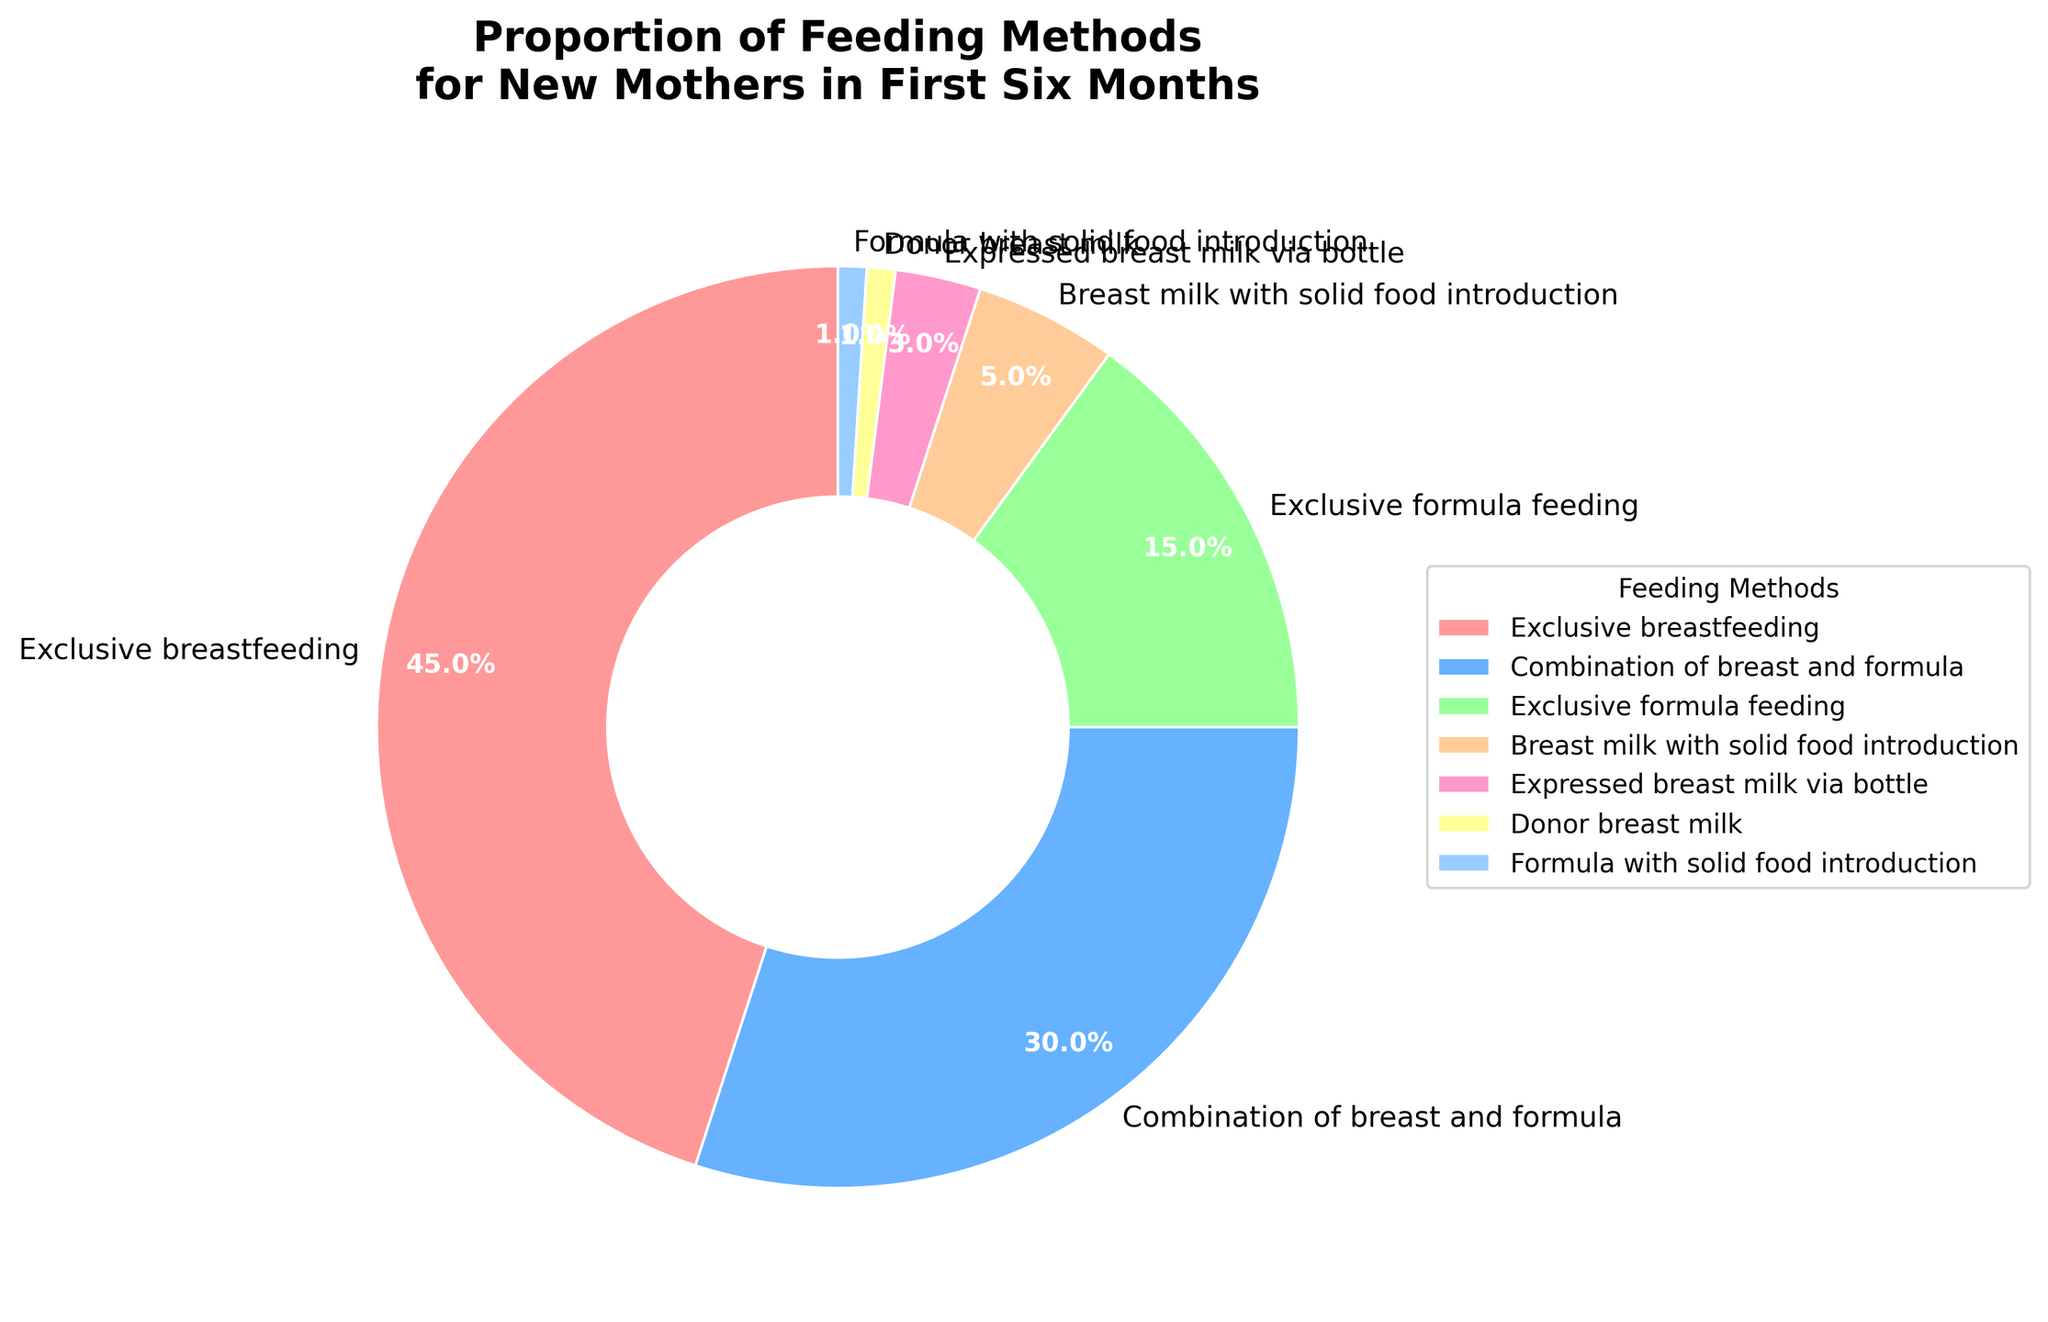What is the most common feeding method used by new mothers in the first six months? The pie chart shows that the largest segment is labeled "Exclusive breastfeeding" with 45%, indicating that it is the most common feeding method.
Answer: Exclusive breastfeeding How much more common is exclusive breastfeeding compared to exclusive formula feeding? The percentage for exclusive breastfeeding is 45%, and for exclusive formula feeding, it is 15%. The difference is 45% - 15%.
Answer: 30% Which feeding method is the least used by new mothers according to the chart? The smallest segment in the pie chart is labeled "Donor breast milk" and "Formula with solid food introduction," each with 1%.
Answer: Donor breast milk and Formula with solid food introduction What percentage of new mothers use some form of breast milk (including exclusive breastfeeding, combination of breast and formula, breast milk with solid food introduction, and expressed breast milk via bottle)? Summing the percentages for exclusive breastfeeding (45%), combination of breast and formula (30%), breast milk with solid food introduction (5%), and expressed breast milk via bottle (3%) gives 45% + 30% + 5% + 3%.
Answer: 83% Compare the usage of combination of breast and formula feeding to expressed breast milk via bottle feeding. Which one is more prevalent and by how much? The segment for combination of breast and formula feeding is 30%, and for expressed breast milk via bottle it is 3%. The difference is 30% - 3%.
Answer: Combination of breast and formula, by 27% Is exclusive breastfeeding used by more than half of the new mothers? The percentage for exclusive breastfeeding is 45%, which is less than half (50%).
Answer: No Arrange the feeding methods from most to least prevalent according to the pie chart. The segments in descending order of size are: Exclusive breastfeeding (45%), combination of breast and formula (30%), exclusive formula feeding (15%), breast milk with solid food introduction (5%), expressed breast milk via bottle (3%), donor breast milk (1%), and formula with solid food introduction (1%).
Answer: Exclusive breastfeeding, combination of breast and formula, exclusive formula feeding, breast milk with solid food introduction, expressed breast milk via bottle, donor breast milk, formula with solid food introduction What is the combined percentage of feeding methods that involve formula feeding (including combination, exclusive formula, and formula with solid food introduction)? Summing the percentages for combination of breast and formula (30%), exclusive formula feeding (15%), and formula with solid food introduction (1%) gives 30% + 15% + 1%.
Answer: 46% What proportion of mothers introduce solid foods within the first six months (including both breast milk and formula with solid food introduction)? Summing the percentages for breast milk with solid food introduction (5%) and formula with solid food introduction (1%) gives 5% + 1%.
Answer: 6% 